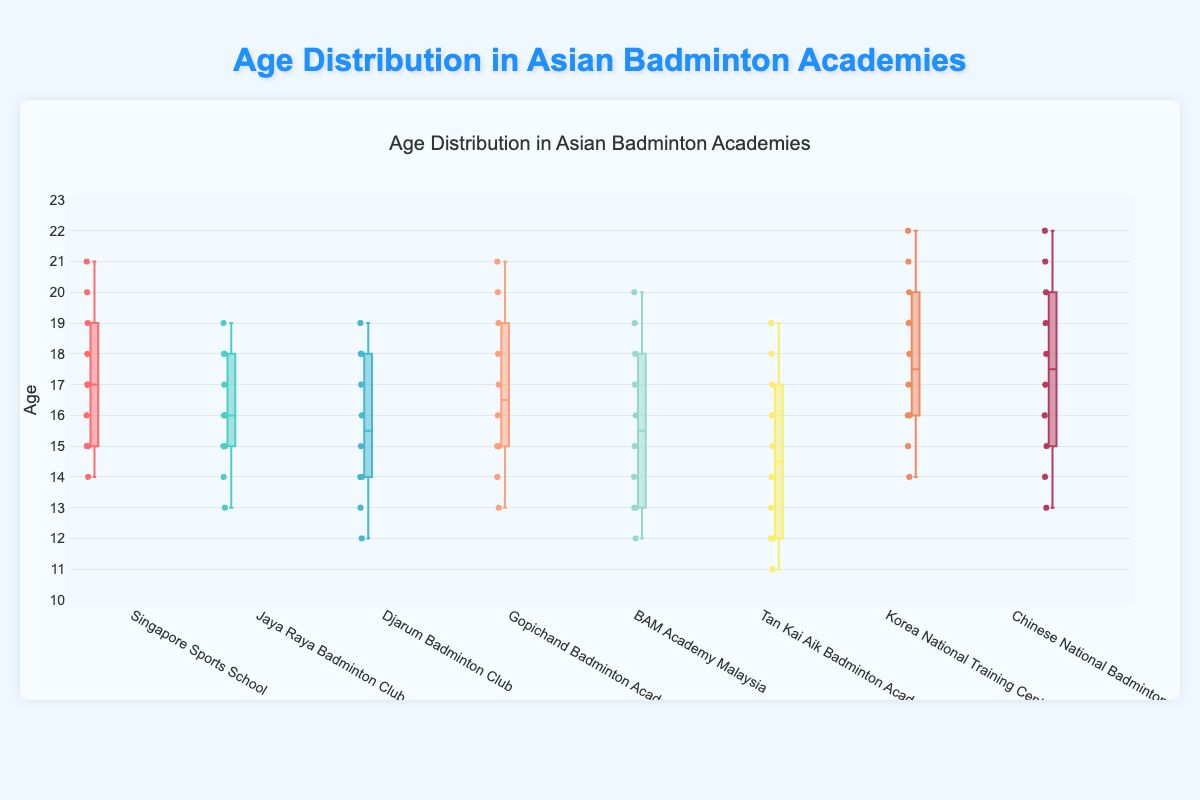What's the title of the figure? The title can be found at the top of the figure.
Answer: Age Distribution in Asian Badminton Academies Which academy has the youngest player? The minimum of the box plots shows the youngest player. Tan Kai Aik Badminton Academy has the youngest player, aged 11.
Answer: Tan Kai Aik Badminton Academy Which academy has the broadest age range? The broadest age range can be identified by comparing the range from the minimum to maximum whiskers in each box plot. Korea National Training Center and Chinese National Badminton Academy both span from 13 to 22 years old.
Answer: Korea National Training Center and Chinese National Badminton Academy What's the median age of players in the Singapore Sports School? The median is represented by the line within the box. For Singapore Sports School, the median is 17.
Answer: 17 Which academies have a median age below 17? The median is represented by the line within each box. The academies with a median line below 17 are Djarum Badminton Club, Jaya Raya Badminton Club, BAM Academy Malaysia, and Tan Kai Aik Badminton Academy.
Answer: Djarum Badminton Club, Jaya Raya Badminton Club, BAM Academy Malaysia, and Tan Kai Aik Badminton Academy Which academy has the highest maximum age? The highest maximum is indicated by the top whisker in each box plot. Korea National Training Center and Chinese National Badminton Academy both have a maximum age of 22.
Answer: Korea National Training Center and Chinese National Badminton Academy What's the interquartile range (IQR) for Gopichand Badminton Academy? The IQR is found by subtracting the first quartile (Q1) from the third quartile (Q3) in the box. For Gopichand Badminton Academy, Q1 is around 15 and Q3 is around 19. So, IQR = 19 - 15 = 4.
Answer: 4 Compare the age distributions between Singapore Sports School and Jaya Raya Badminton Club. Which has the smaller spread? The spread can be inferred from the whiskers and the length of the box. Jaya Raya Badminton Club has a smaller spread compared to Singapore Sports School as its box and whiskers are more compact.
Answer: Jaya Raya Badminton Club How many points are plotted for each academy? The number of points can be inferred from the 'boxpoints' attribute, which indicates all points are plotted. Each academy has 10 points.
Answer: 10 In which academy do players' ages span from the age of 12 to 20? By looking at the whiskers of each box plot, BAM Academy Malaysia is the one spanning from 12 to 20 years.
Answer: BAM Academy Malaysia 